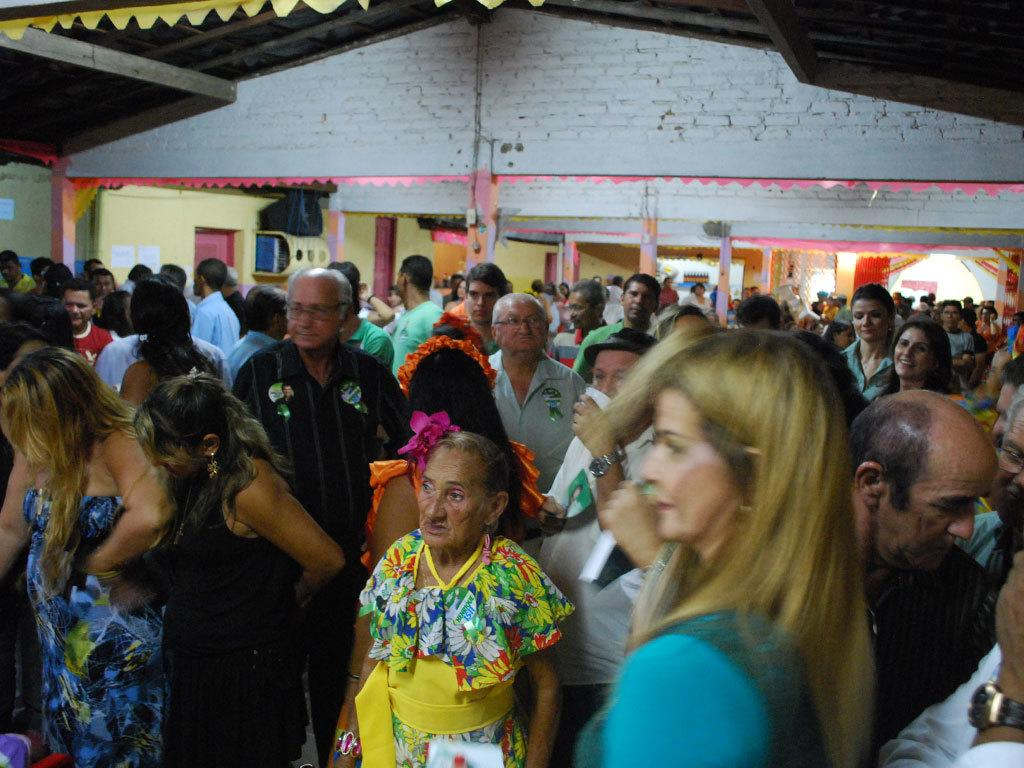What is the main subject of the image? The main subject of the image is a huge crowd. Where is the crowd located? The crowd is in front of a building. What type of structure is providing shelter for the crowd? The crowd is standing under a roof. How many spies can be seen in the image? There is no mention of spies in the image, so it is impossible to determine their presence or number. 